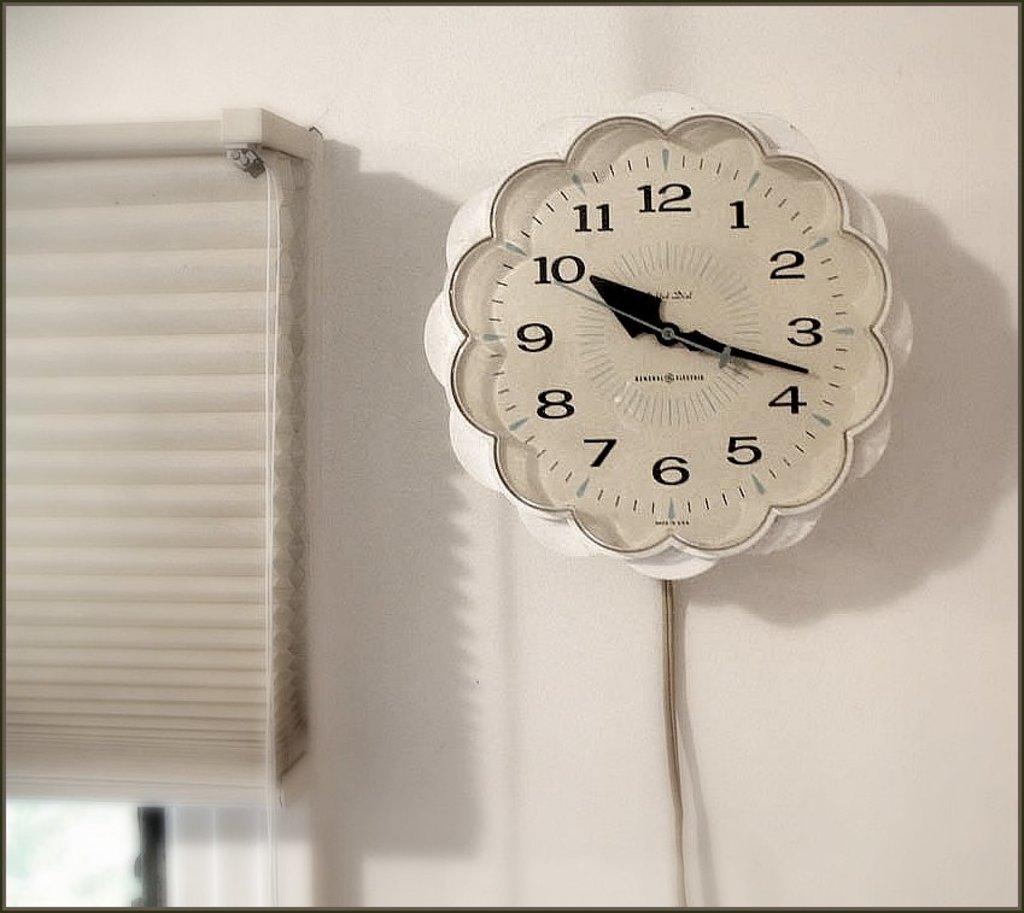What number is the small hand pointing to?
Make the answer very short. 10. What time is it?
Give a very brief answer. 10:18. 